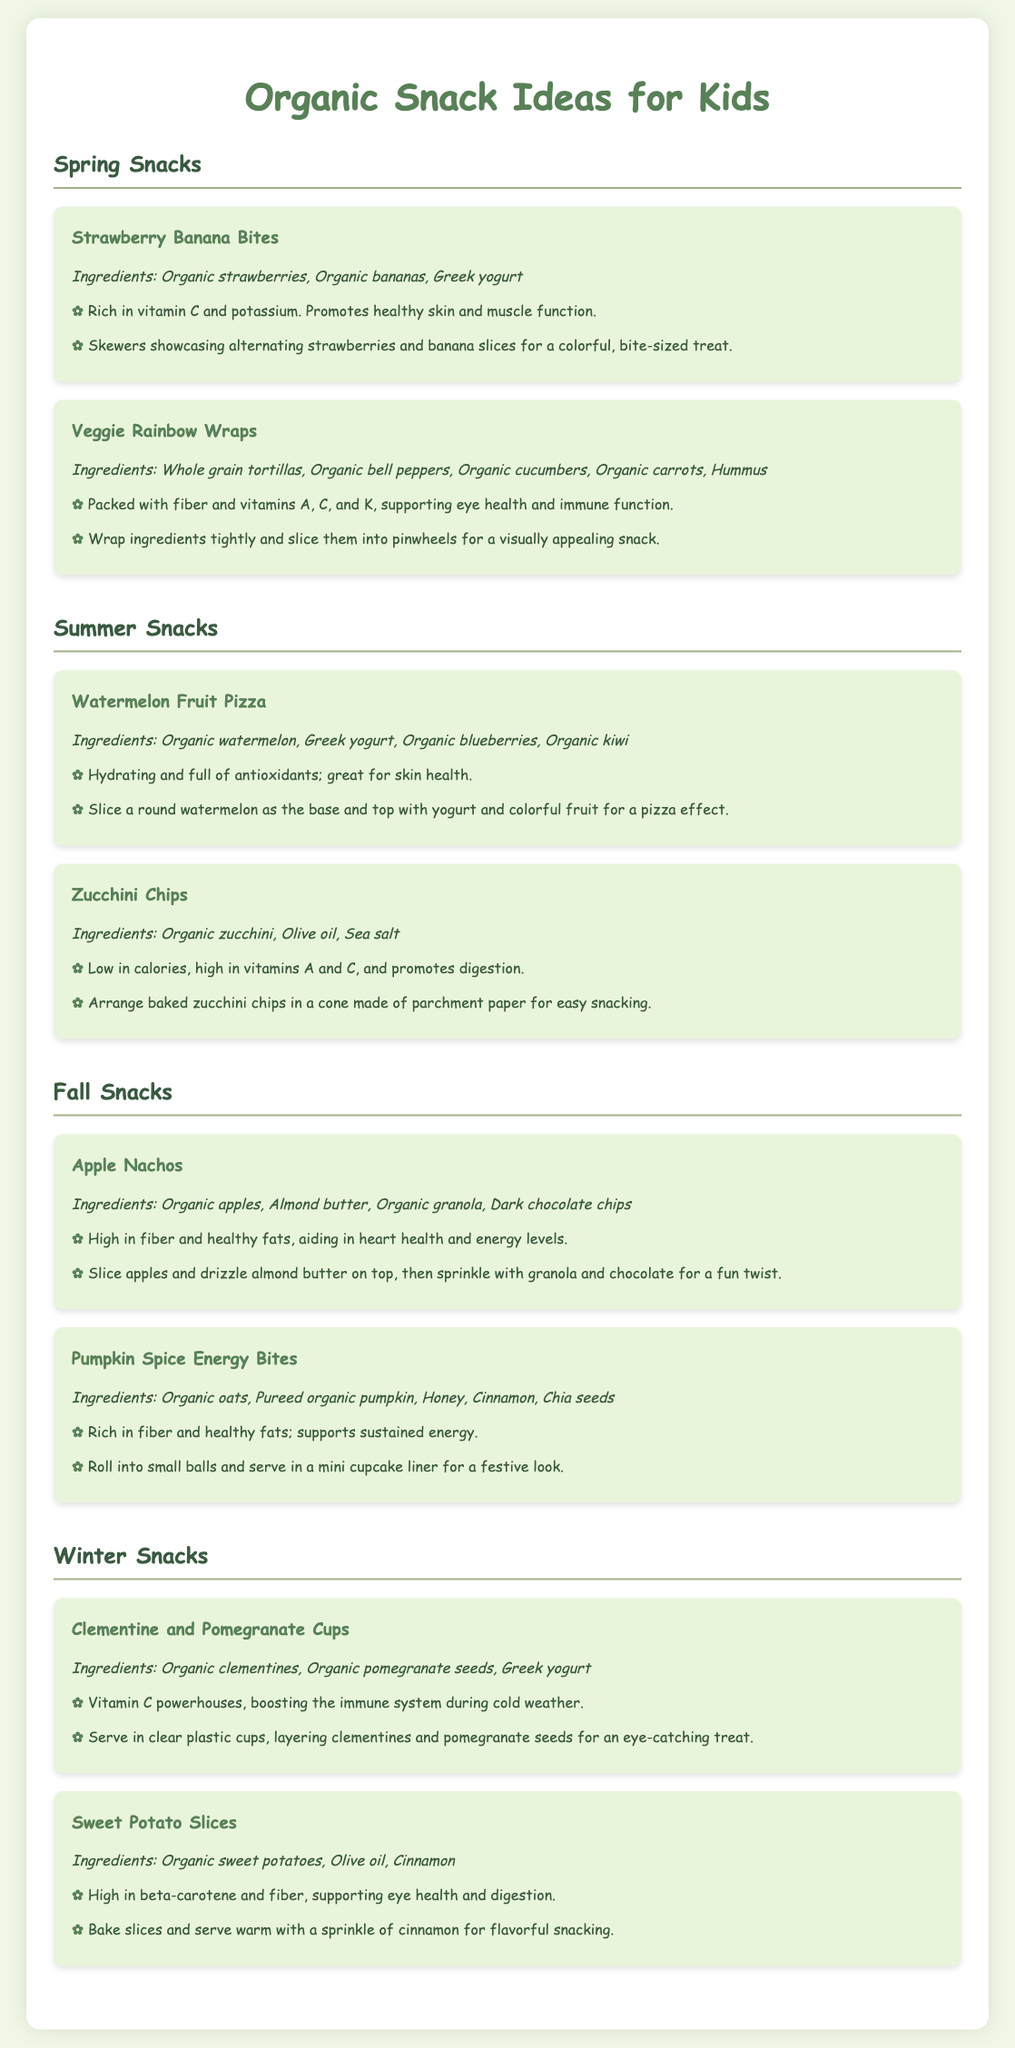what is the title of the document? The title of the document is located in the <title> tag in the head section, which specifies the topic of the content.
Answer: Organic Snack Ideas for Kids how many snack items are listed in the spring snacks section? The spring snacks section includes two snack items, based on how many are described within that specific section.
Answer: 2 what is the main ingredient in Veggie Rainbow Wraps? The main ingredients of Veggie Rainbow Wraps can be found in the ingredients list for that specific snack item.
Answer: Whole grain tortillas what seasonal fruits are used in the Watermelon Fruit Pizza? The seasonal fruits are outlined in the ingredients section of the Watermelon Fruit Pizza snack item.
Answer: Watermelon, blueberries, kiwi which snack contains almond butter? The snack item that mentions almond butter is identified in its description, which is related to its ingredients.
Answer: Apple Nachos what nutritional benefit is highlighted for pumpkin spice energy bites? The benefits of pumpkin spice energy bites are indicated in a benefits section, reflecting its health aspects.
Answer: Supports sustained energy how are the clementine and pomegranate cups presented? The presentation details for clementine and pomegranate cups describe how the snack is visually served to enhance appeal.
Answer: In clear plastic cups what is the primary benefit of zucchini chips? The document outlines the nutritional benefits associated with eating zucchini chips in the benefits section.
Answer: Promotes digestion 